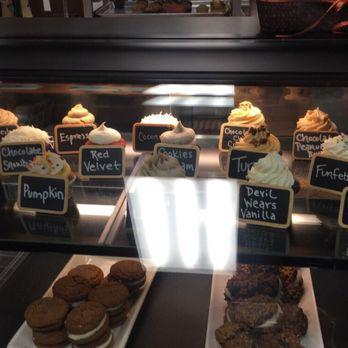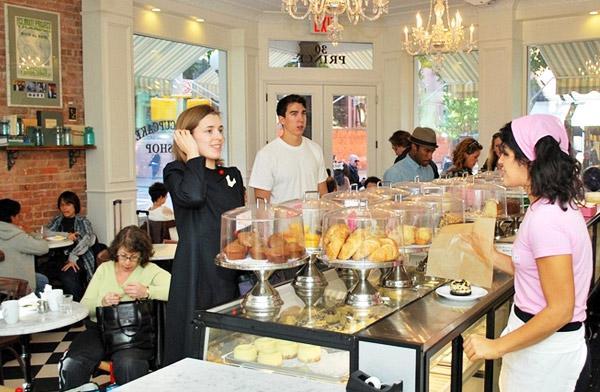The first image is the image on the left, the second image is the image on the right. Analyze the images presented: Is the assertion "An image shows a female worker by a glass case, wearing a scarf on her head." valid? Answer yes or no. Yes. The first image is the image on the left, the second image is the image on the right. Given the left and right images, does the statement "a woman behind the counter is wearing a head wrap." hold true? Answer yes or no. Yes. 